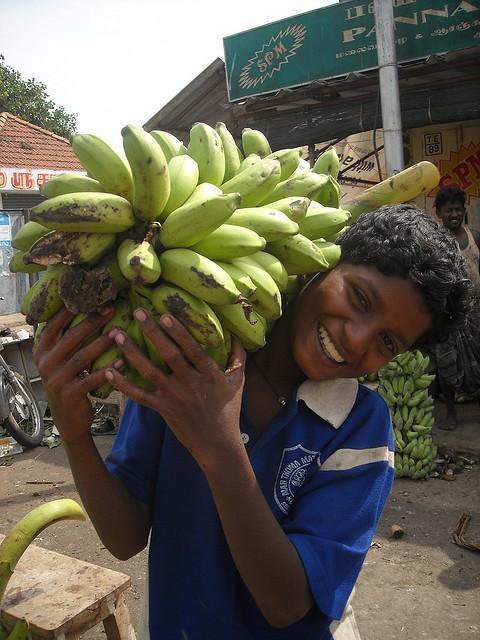How many bananas are there?
Give a very brief answer. 2. 